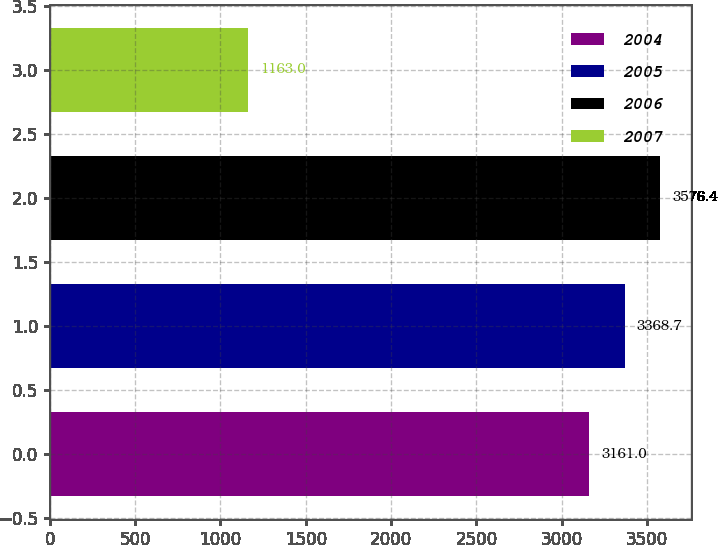<chart> <loc_0><loc_0><loc_500><loc_500><bar_chart><fcel>2004<fcel>2005<fcel>2006<fcel>2007<nl><fcel>3161<fcel>3368.7<fcel>3576.4<fcel>1163<nl></chart> 